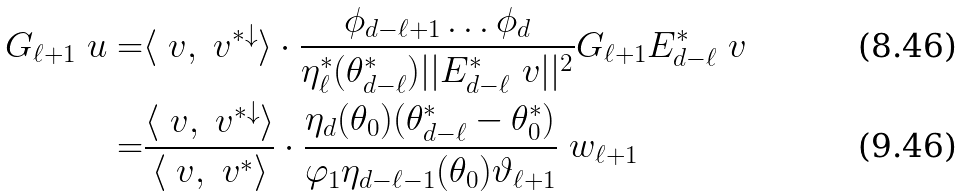<formula> <loc_0><loc_0><loc_500><loc_500>G _ { \ell + 1 } \ u = & \langle \ v , \ v ^ { * \downarrow } \rangle \cdot \frac { \phi _ { d - \ell + 1 } \dots \phi _ { d } } { \eta _ { \ell } ^ { * } ( \theta _ { d - \ell } ^ { * } ) | | E _ { d - \ell } ^ { * } \ v | | ^ { 2 } } G _ { \ell + 1 } E _ { d - \ell } ^ { * } \ v \\ = & \frac { \langle \ v , \ v ^ { * \downarrow } \rangle } { \langle \ v , \ v ^ { * } \rangle } \cdot \frac { \eta _ { d } ( \theta _ { 0 } ) ( \theta _ { d - \ell } ^ { * } - \theta _ { 0 } ^ { * } ) } { \varphi _ { 1 } \eta _ { d - \ell - 1 } ( \theta _ { 0 } ) \vartheta _ { \ell + 1 } } \ w _ { \ell + 1 }</formula> 